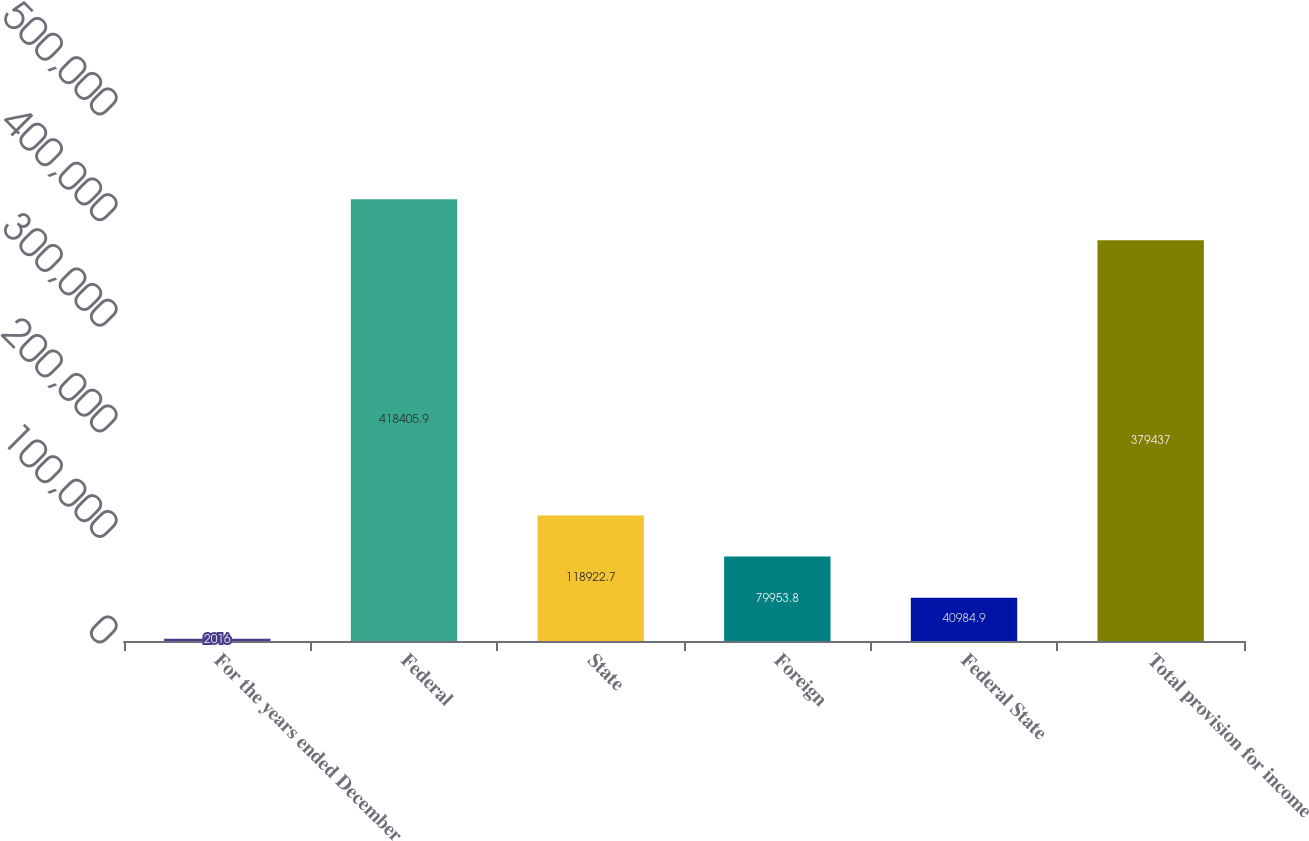<chart> <loc_0><loc_0><loc_500><loc_500><bar_chart><fcel>For the years ended December<fcel>Federal<fcel>State<fcel>Foreign<fcel>Federal State<fcel>Total provision for income<nl><fcel>2016<fcel>418406<fcel>118923<fcel>79953.8<fcel>40984.9<fcel>379437<nl></chart> 